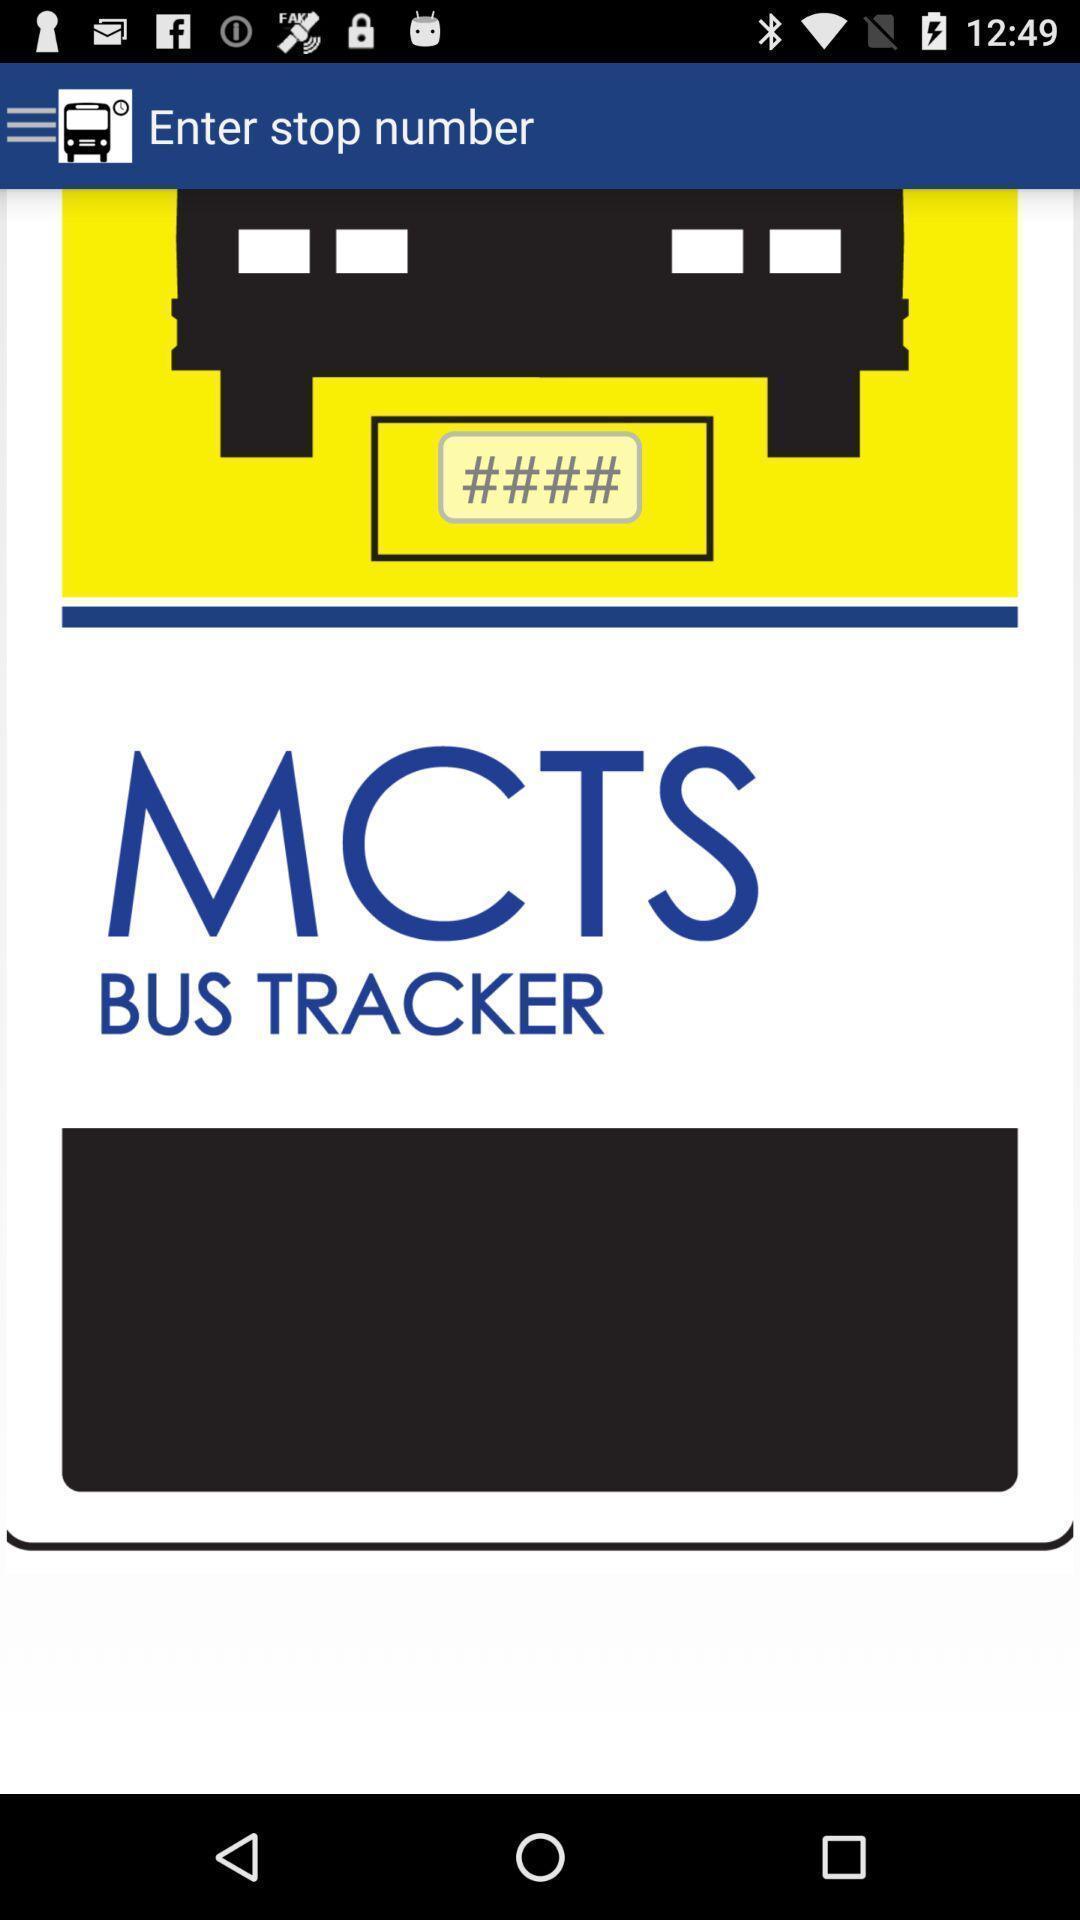Provide a detailed account of this screenshot. Screen shows about bus tracker. 